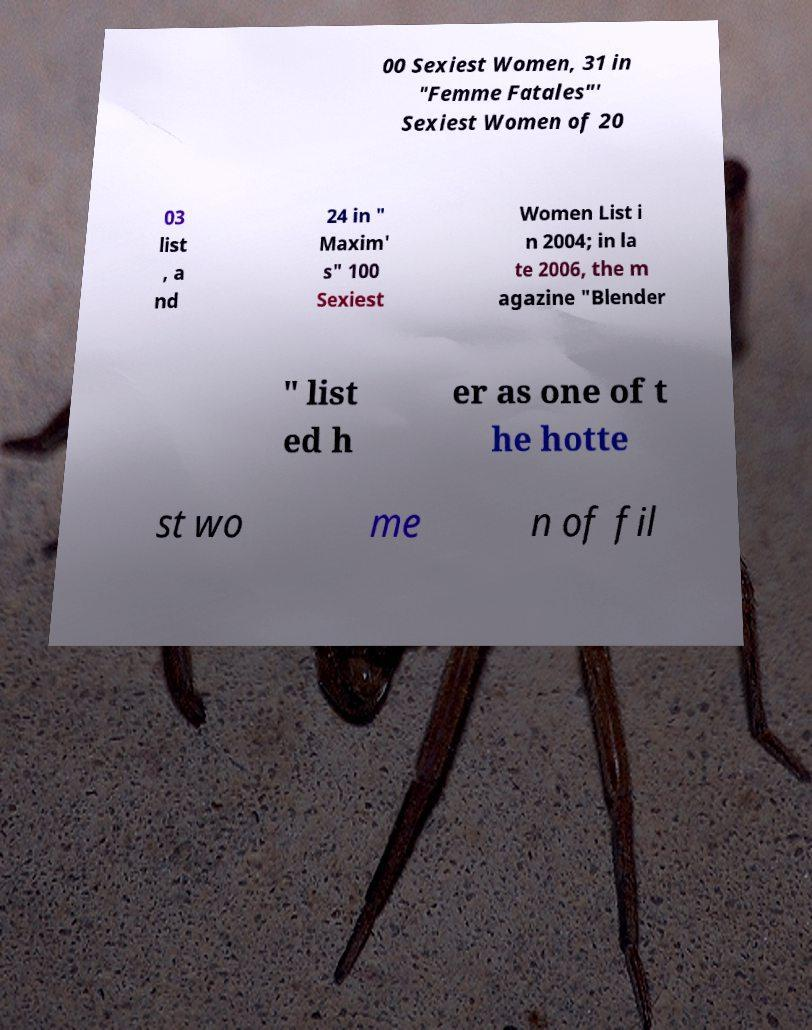What messages or text are displayed in this image? I need them in a readable, typed format. 00 Sexiest Women, 31 in "Femme Fatales"' Sexiest Women of 20 03 list , a nd 24 in " Maxim' s" 100 Sexiest Women List i n 2004; in la te 2006, the m agazine "Blender " list ed h er as one of t he hotte st wo me n of fil 